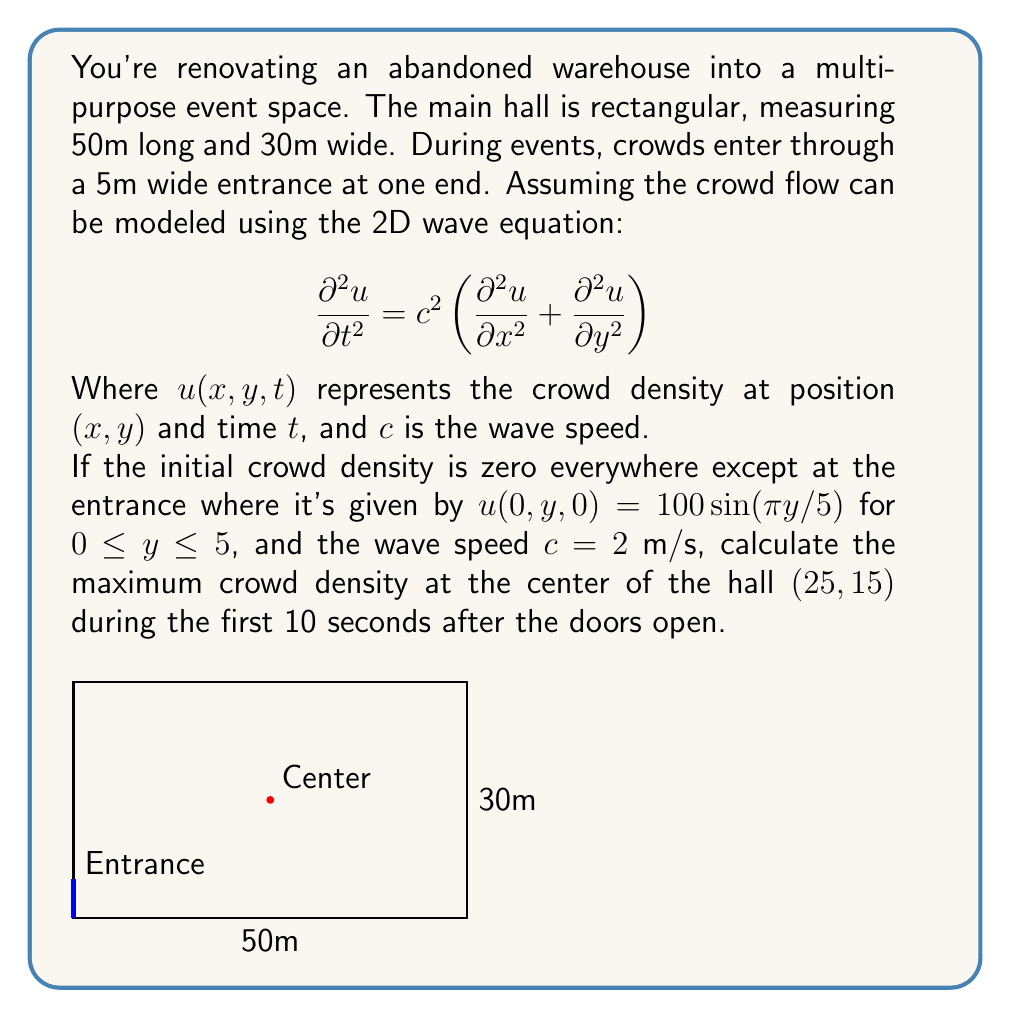Can you solve this math problem? To solve this problem, we need to use the solution of the 2D wave equation for a rectangular domain. The general solution is:

$$u(x,y,t) = \sum_{m=1}^{\infty}\sum_{n=1}^{\infty} A_{mn} \sin(\frac{m\pi x}{L}) \sin(\frac{n\pi y}{W}) \cos(\omega_{mn}t)$$

Where $L=50$ and $W=30$ are the length and width of the hall, and $\omega_{mn} = c\pi\sqrt{(\frac{m}{L})^2 + (\frac{n}{W})^2}$.

Given the initial condition, we can see that only the terms with $m=1$ and $n=1$ will be non-zero. Therefore:

$$u(x,y,t) = A_{11} \sin(\frac{\pi x}{50}) \sin(\frac{\pi y}{30}) \cos(\omega_{11}t)$$

To find $A_{11}$, we need to match the initial condition:

$$100 \sin(\frac{\pi y}{5}) = A_{11} \sin(\frac{\pi \cdot 0}{50}) \sin(\frac{\pi y}{30})$$

This gives us $A_{11} = 600$.

Now, $\omega_{11} = 2\pi\sqrt{(\frac{1}{50})^2 + (\frac{1}{30})^2} \approx 0.1483$ rad/s

At the center point (25,15), we have:

$$u(25,15,t) = 600 \sin(\frac{\pi}{2}) \sin(\frac{\pi}{2}) \cos(0.1483t) = 600\cos(0.1483t)$$

The maximum value of this function over the first 10 seconds occurs when $\cos(0.1483t) = 1$, which gives us a maximum crowd density of 600 people/m².
Answer: 600 people/m² 